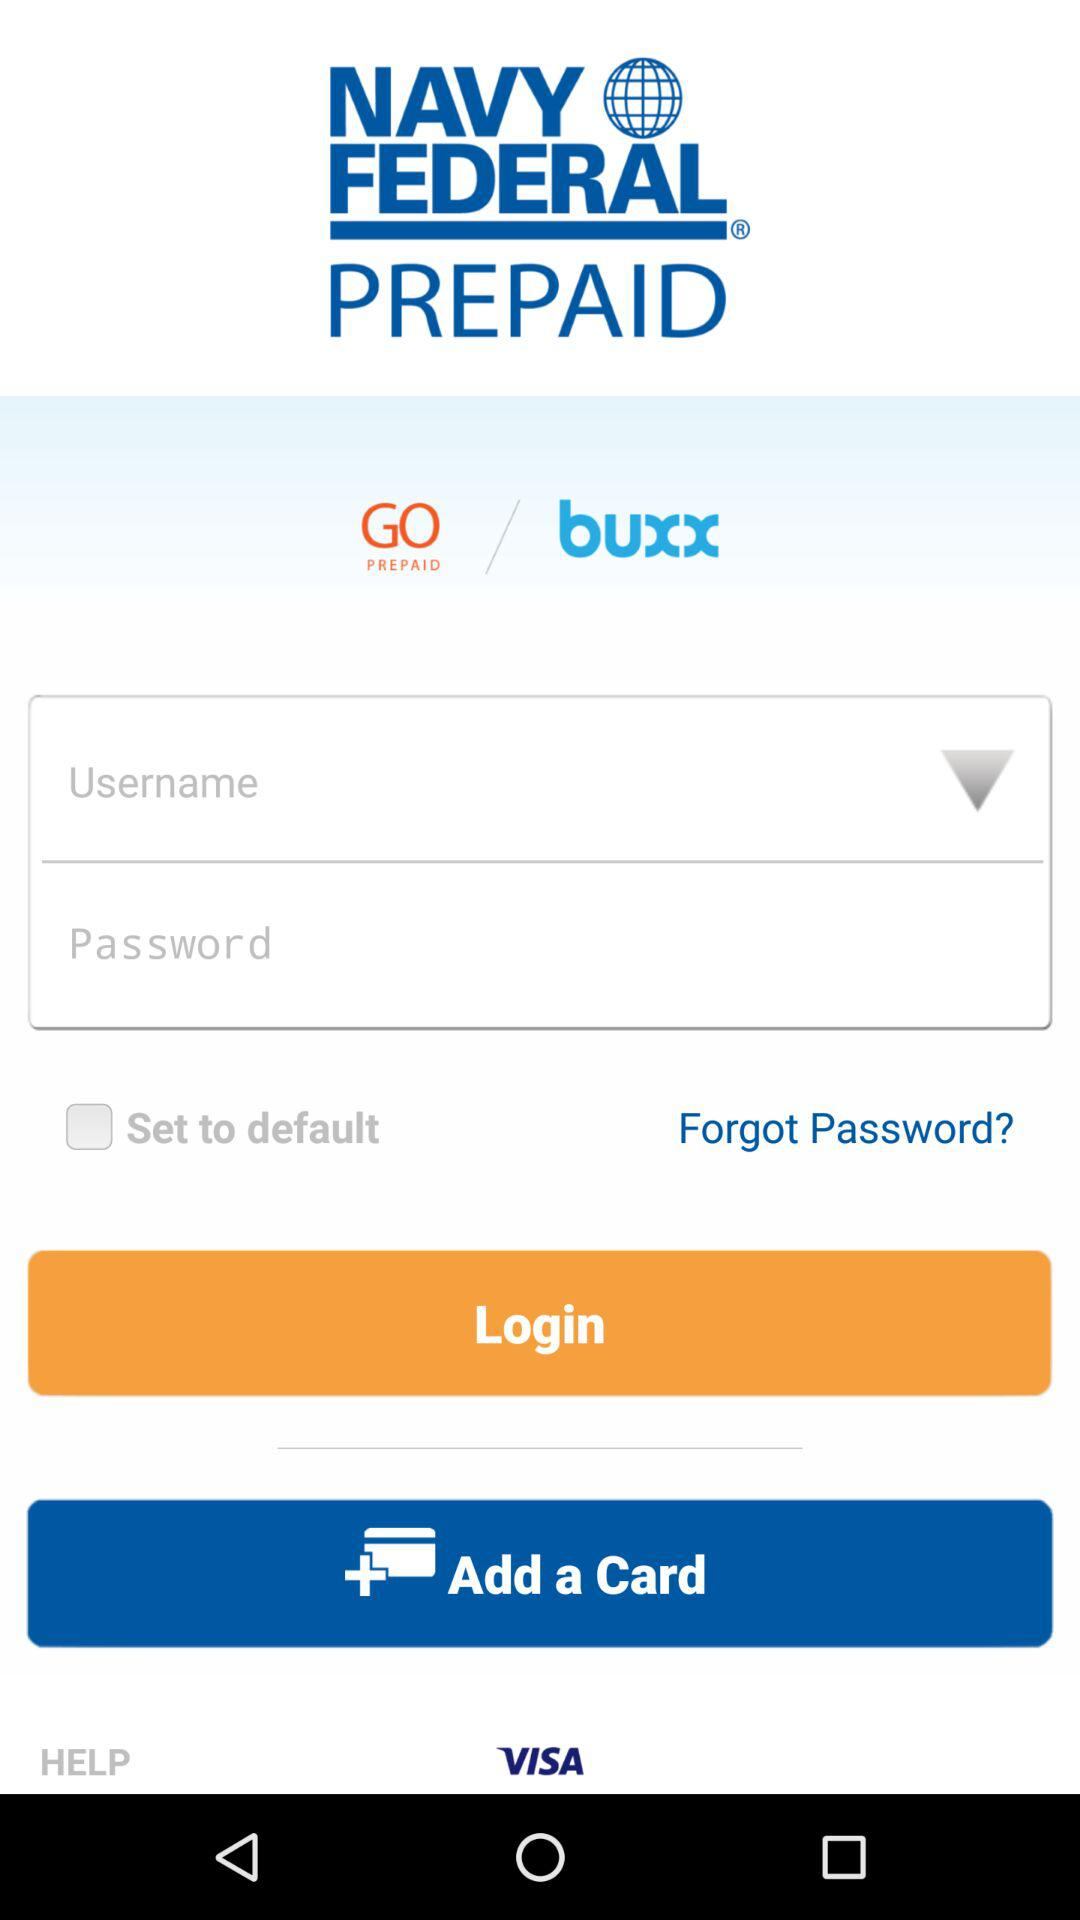What is the name of the application? The name of the application is "NAVY FEDERAL PREPAID". 